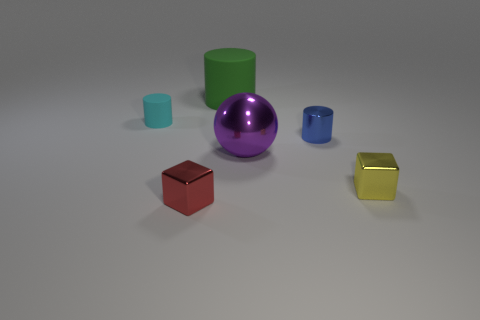How many objects can be seen in the image? There are five objects visible in the image, each with a unique color and shape. 